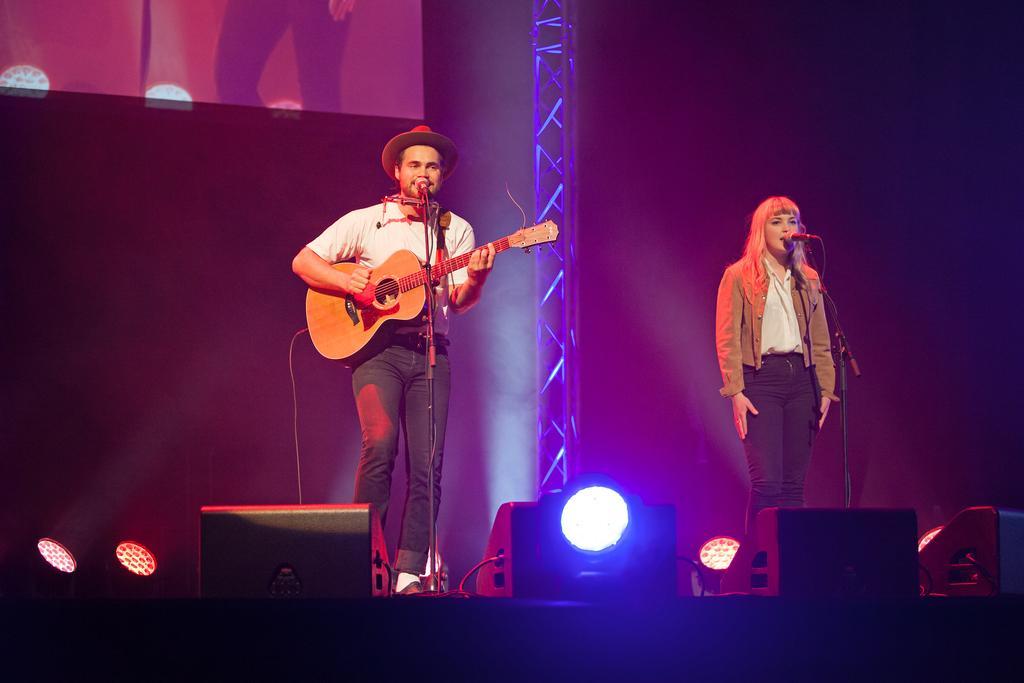How would you summarize this image in a sentence or two? In this image there are two persons at the left side of the image there is a man who is playing guitar and at the right side of the image there is woman who is singing and at the bottom of the image there are lights and sound boxes 